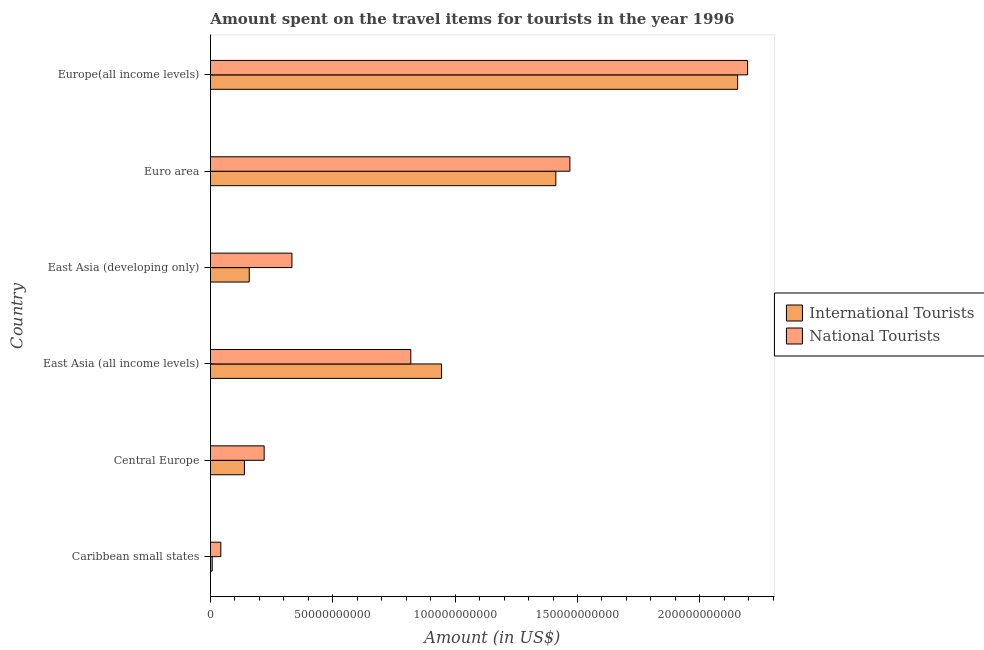Are the number of bars per tick equal to the number of legend labels?
Ensure brevity in your answer.  Yes. Are the number of bars on each tick of the Y-axis equal?
Keep it short and to the point. Yes. How many bars are there on the 2nd tick from the top?
Ensure brevity in your answer.  2. What is the label of the 2nd group of bars from the top?
Your answer should be very brief. Euro area. What is the amount spent on travel items of national tourists in East Asia (all income levels)?
Make the answer very short. 8.19e+1. Across all countries, what is the maximum amount spent on travel items of national tourists?
Provide a succinct answer. 2.20e+11. Across all countries, what is the minimum amount spent on travel items of international tourists?
Make the answer very short. 7.15e+08. In which country was the amount spent on travel items of national tourists maximum?
Your answer should be compact. Europe(all income levels). In which country was the amount spent on travel items of international tourists minimum?
Offer a terse response. Caribbean small states. What is the total amount spent on travel items of national tourists in the graph?
Your answer should be very brief. 5.08e+11. What is the difference between the amount spent on travel items of national tourists in Central Europe and that in Euro area?
Provide a short and direct response. -1.25e+11. What is the difference between the amount spent on travel items of international tourists in Europe(all income levels) and the amount spent on travel items of national tourists in East Asia (all income levels)?
Offer a terse response. 1.34e+11. What is the average amount spent on travel items of national tourists per country?
Your response must be concise. 8.46e+1. What is the difference between the amount spent on travel items of national tourists and amount spent on travel items of international tourists in Caribbean small states?
Your response must be concise. 3.51e+09. In how many countries, is the amount spent on travel items of national tourists greater than 90000000000 US$?
Give a very brief answer. 2. What is the ratio of the amount spent on travel items of international tourists in Central Europe to that in Euro area?
Your answer should be very brief. 0.1. What is the difference between the highest and the second highest amount spent on travel items of national tourists?
Offer a very short reply. 7.26e+1. What is the difference between the highest and the lowest amount spent on travel items of international tourists?
Your answer should be very brief. 2.15e+11. In how many countries, is the amount spent on travel items of national tourists greater than the average amount spent on travel items of national tourists taken over all countries?
Offer a very short reply. 2. What does the 2nd bar from the top in East Asia (all income levels) represents?
Your answer should be compact. International Tourists. What does the 1st bar from the bottom in Central Europe represents?
Offer a terse response. International Tourists. Are all the bars in the graph horizontal?
Ensure brevity in your answer.  Yes. What is the difference between two consecutive major ticks on the X-axis?
Your answer should be compact. 5.00e+1. Does the graph contain grids?
Ensure brevity in your answer.  No. Where does the legend appear in the graph?
Offer a very short reply. Center right. What is the title of the graph?
Provide a succinct answer. Amount spent on the travel items for tourists in the year 1996. What is the label or title of the Y-axis?
Offer a terse response. Country. What is the Amount (in US$) of International Tourists in Caribbean small states?
Provide a succinct answer. 7.15e+08. What is the Amount (in US$) in National Tourists in Caribbean small states?
Offer a very short reply. 4.22e+09. What is the Amount (in US$) of International Tourists in Central Europe?
Provide a short and direct response. 1.39e+1. What is the Amount (in US$) of National Tourists in Central Europe?
Your answer should be compact. 2.19e+1. What is the Amount (in US$) in International Tourists in East Asia (all income levels)?
Give a very brief answer. 9.44e+1. What is the Amount (in US$) in National Tourists in East Asia (all income levels)?
Provide a short and direct response. 8.19e+1. What is the Amount (in US$) in International Tourists in East Asia (developing only)?
Your answer should be very brief. 1.59e+1. What is the Amount (in US$) of National Tourists in East Asia (developing only)?
Your response must be concise. 3.33e+1. What is the Amount (in US$) of International Tourists in Euro area?
Keep it short and to the point. 1.41e+11. What is the Amount (in US$) of National Tourists in Euro area?
Keep it short and to the point. 1.47e+11. What is the Amount (in US$) in International Tourists in Europe(all income levels)?
Your response must be concise. 2.15e+11. What is the Amount (in US$) in National Tourists in Europe(all income levels)?
Offer a very short reply. 2.20e+11. Across all countries, what is the maximum Amount (in US$) in International Tourists?
Offer a terse response. 2.15e+11. Across all countries, what is the maximum Amount (in US$) of National Tourists?
Keep it short and to the point. 2.20e+11. Across all countries, what is the minimum Amount (in US$) in International Tourists?
Provide a succinct answer. 7.15e+08. Across all countries, what is the minimum Amount (in US$) of National Tourists?
Provide a short and direct response. 4.22e+09. What is the total Amount (in US$) of International Tourists in the graph?
Offer a terse response. 4.81e+11. What is the total Amount (in US$) of National Tourists in the graph?
Ensure brevity in your answer.  5.08e+11. What is the difference between the Amount (in US$) of International Tourists in Caribbean small states and that in Central Europe?
Keep it short and to the point. -1.32e+1. What is the difference between the Amount (in US$) of National Tourists in Caribbean small states and that in Central Europe?
Ensure brevity in your answer.  -1.77e+1. What is the difference between the Amount (in US$) of International Tourists in Caribbean small states and that in East Asia (all income levels)?
Give a very brief answer. -9.37e+1. What is the difference between the Amount (in US$) in National Tourists in Caribbean small states and that in East Asia (all income levels)?
Make the answer very short. -7.77e+1. What is the difference between the Amount (in US$) in International Tourists in Caribbean small states and that in East Asia (developing only)?
Your response must be concise. -1.51e+1. What is the difference between the Amount (in US$) of National Tourists in Caribbean small states and that in East Asia (developing only)?
Give a very brief answer. -2.91e+1. What is the difference between the Amount (in US$) of International Tourists in Caribbean small states and that in Euro area?
Offer a very short reply. -1.40e+11. What is the difference between the Amount (in US$) in National Tourists in Caribbean small states and that in Euro area?
Offer a terse response. -1.43e+11. What is the difference between the Amount (in US$) of International Tourists in Caribbean small states and that in Europe(all income levels)?
Provide a short and direct response. -2.15e+11. What is the difference between the Amount (in US$) of National Tourists in Caribbean small states and that in Europe(all income levels)?
Ensure brevity in your answer.  -2.15e+11. What is the difference between the Amount (in US$) in International Tourists in Central Europe and that in East Asia (all income levels)?
Provide a short and direct response. -8.06e+1. What is the difference between the Amount (in US$) in National Tourists in Central Europe and that in East Asia (all income levels)?
Provide a succinct answer. -5.99e+1. What is the difference between the Amount (in US$) in International Tourists in Central Europe and that in East Asia (developing only)?
Offer a very short reply. -1.97e+09. What is the difference between the Amount (in US$) in National Tourists in Central Europe and that in East Asia (developing only)?
Give a very brief answer. -1.13e+1. What is the difference between the Amount (in US$) in International Tourists in Central Europe and that in Euro area?
Give a very brief answer. -1.27e+11. What is the difference between the Amount (in US$) of National Tourists in Central Europe and that in Euro area?
Give a very brief answer. -1.25e+11. What is the difference between the Amount (in US$) of International Tourists in Central Europe and that in Europe(all income levels)?
Your response must be concise. -2.02e+11. What is the difference between the Amount (in US$) of National Tourists in Central Europe and that in Europe(all income levels)?
Keep it short and to the point. -1.98e+11. What is the difference between the Amount (in US$) in International Tourists in East Asia (all income levels) and that in East Asia (developing only)?
Provide a succinct answer. 7.86e+1. What is the difference between the Amount (in US$) of National Tourists in East Asia (all income levels) and that in East Asia (developing only)?
Your answer should be compact. 4.86e+1. What is the difference between the Amount (in US$) in International Tourists in East Asia (all income levels) and that in Euro area?
Ensure brevity in your answer.  -4.67e+1. What is the difference between the Amount (in US$) of National Tourists in East Asia (all income levels) and that in Euro area?
Offer a terse response. -6.50e+1. What is the difference between the Amount (in US$) in International Tourists in East Asia (all income levels) and that in Europe(all income levels)?
Your answer should be compact. -1.21e+11. What is the difference between the Amount (in US$) of National Tourists in East Asia (all income levels) and that in Europe(all income levels)?
Your answer should be compact. -1.38e+11. What is the difference between the Amount (in US$) of International Tourists in East Asia (developing only) and that in Euro area?
Give a very brief answer. -1.25e+11. What is the difference between the Amount (in US$) in National Tourists in East Asia (developing only) and that in Euro area?
Provide a short and direct response. -1.14e+11. What is the difference between the Amount (in US$) of International Tourists in East Asia (developing only) and that in Europe(all income levels)?
Your response must be concise. -2.00e+11. What is the difference between the Amount (in US$) in National Tourists in East Asia (developing only) and that in Europe(all income levels)?
Your answer should be very brief. -1.86e+11. What is the difference between the Amount (in US$) of International Tourists in Euro area and that in Europe(all income levels)?
Your answer should be compact. -7.43e+1. What is the difference between the Amount (in US$) of National Tourists in Euro area and that in Europe(all income levels)?
Ensure brevity in your answer.  -7.26e+1. What is the difference between the Amount (in US$) of International Tourists in Caribbean small states and the Amount (in US$) of National Tourists in Central Europe?
Keep it short and to the point. -2.12e+1. What is the difference between the Amount (in US$) in International Tourists in Caribbean small states and the Amount (in US$) in National Tourists in East Asia (all income levels)?
Keep it short and to the point. -8.12e+1. What is the difference between the Amount (in US$) of International Tourists in Caribbean small states and the Amount (in US$) of National Tourists in East Asia (developing only)?
Make the answer very short. -3.26e+1. What is the difference between the Amount (in US$) of International Tourists in Caribbean small states and the Amount (in US$) of National Tourists in Euro area?
Offer a very short reply. -1.46e+11. What is the difference between the Amount (in US$) in International Tourists in Caribbean small states and the Amount (in US$) in National Tourists in Europe(all income levels)?
Provide a short and direct response. -2.19e+11. What is the difference between the Amount (in US$) in International Tourists in Central Europe and the Amount (in US$) in National Tourists in East Asia (all income levels)?
Make the answer very short. -6.80e+1. What is the difference between the Amount (in US$) in International Tourists in Central Europe and the Amount (in US$) in National Tourists in East Asia (developing only)?
Make the answer very short. -1.94e+1. What is the difference between the Amount (in US$) of International Tourists in Central Europe and the Amount (in US$) of National Tourists in Euro area?
Provide a succinct answer. -1.33e+11. What is the difference between the Amount (in US$) of International Tourists in Central Europe and the Amount (in US$) of National Tourists in Europe(all income levels)?
Give a very brief answer. -2.06e+11. What is the difference between the Amount (in US$) of International Tourists in East Asia (all income levels) and the Amount (in US$) of National Tourists in East Asia (developing only)?
Give a very brief answer. 6.11e+1. What is the difference between the Amount (in US$) in International Tourists in East Asia (all income levels) and the Amount (in US$) in National Tourists in Euro area?
Provide a short and direct response. -5.25e+1. What is the difference between the Amount (in US$) in International Tourists in East Asia (all income levels) and the Amount (in US$) in National Tourists in Europe(all income levels)?
Ensure brevity in your answer.  -1.25e+11. What is the difference between the Amount (in US$) in International Tourists in East Asia (developing only) and the Amount (in US$) in National Tourists in Euro area?
Offer a very short reply. -1.31e+11. What is the difference between the Amount (in US$) of International Tourists in East Asia (developing only) and the Amount (in US$) of National Tourists in Europe(all income levels)?
Your answer should be compact. -2.04e+11. What is the difference between the Amount (in US$) of International Tourists in Euro area and the Amount (in US$) of National Tourists in Europe(all income levels)?
Provide a short and direct response. -7.84e+1. What is the average Amount (in US$) of International Tourists per country?
Your answer should be compact. 8.02e+1. What is the average Amount (in US$) in National Tourists per country?
Offer a terse response. 8.46e+1. What is the difference between the Amount (in US$) of International Tourists and Amount (in US$) of National Tourists in Caribbean small states?
Give a very brief answer. -3.51e+09. What is the difference between the Amount (in US$) of International Tourists and Amount (in US$) of National Tourists in Central Europe?
Keep it short and to the point. -8.06e+09. What is the difference between the Amount (in US$) in International Tourists and Amount (in US$) in National Tourists in East Asia (all income levels)?
Offer a very short reply. 1.26e+1. What is the difference between the Amount (in US$) of International Tourists and Amount (in US$) of National Tourists in East Asia (developing only)?
Give a very brief answer. -1.74e+1. What is the difference between the Amount (in US$) of International Tourists and Amount (in US$) of National Tourists in Euro area?
Offer a terse response. -5.74e+09. What is the difference between the Amount (in US$) of International Tourists and Amount (in US$) of National Tourists in Europe(all income levels)?
Your response must be concise. -4.06e+09. What is the ratio of the Amount (in US$) in International Tourists in Caribbean small states to that in Central Europe?
Keep it short and to the point. 0.05. What is the ratio of the Amount (in US$) in National Tourists in Caribbean small states to that in Central Europe?
Your answer should be compact. 0.19. What is the ratio of the Amount (in US$) of International Tourists in Caribbean small states to that in East Asia (all income levels)?
Keep it short and to the point. 0.01. What is the ratio of the Amount (in US$) of National Tourists in Caribbean small states to that in East Asia (all income levels)?
Your answer should be compact. 0.05. What is the ratio of the Amount (in US$) of International Tourists in Caribbean small states to that in East Asia (developing only)?
Your response must be concise. 0.05. What is the ratio of the Amount (in US$) in National Tourists in Caribbean small states to that in East Asia (developing only)?
Provide a short and direct response. 0.13. What is the ratio of the Amount (in US$) in International Tourists in Caribbean small states to that in Euro area?
Make the answer very short. 0.01. What is the ratio of the Amount (in US$) of National Tourists in Caribbean small states to that in Euro area?
Make the answer very short. 0.03. What is the ratio of the Amount (in US$) of International Tourists in Caribbean small states to that in Europe(all income levels)?
Ensure brevity in your answer.  0. What is the ratio of the Amount (in US$) in National Tourists in Caribbean small states to that in Europe(all income levels)?
Keep it short and to the point. 0.02. What is the ratio of the Amount (in US$) of International Tourists in Central Europe to that in East Asia (all income levels)?
Your answer should be compact. 0.15. What is the ratio of the Amount (in US$) of National Tourists in Central Europe to that in East Asia (all income levels)?
Your answer should be compact. 0.27. What is the ratio of the Amount (in US$) in International Tourists in Central Europe to that in East Asia (developing only)?
Your answer should be compact. 0.88. What is the ratio of the Amount (in US$) of National Tourists in Central Europe to that in East Asia (developing only)?
Offer a very short reply. 0.66. What is the ratio of the Amount (in US$) in International Tourists in Central Europe to that in Euro area?
Offer a terse response. 0.1. What is the ratio of the Amount (in US$) in National Tourists in Central Europe to that in Euro area?
Offer a very short reply. 0.15. What is the ratio of the Amount (in US$) of International Tourists in Central Europe to that in Europe(all income levels)?
Provide a succinct answer. 0.06. What is the ratio of the Amount (in US$) in National Tourists in Central Europe to that in Europe(all income levels)?
Offer a terse response. 0.1. What is the ratio of the Amount (in US$) of International Tourists in East Asia (all income levels) to that in East Asia (developing only)?
Your answer should be very brief. 5.96. What is the ratio of the Amount (in US$) of National Tourists in East Asia (all income levels) to that in East Asia (developing only)?
Ensure brevity in your answer.  2.46. What is the ratio of the Amount (in US$) in International Tourists in East Asia (all income levels) to that in Euro area?
Your answer should be very brief. 0.67. What is the ratio of the Amount (in US$) of National Tourists in East Asia (all income levels) to that in Euro area?
Provide a succinct answer. 0.56. What is the ratio of the Amount (in US$) in International Tourists in East Asia (all income levels) to that in Europe(all income levels)?
Provide a succinct answer. 0.44. What is the ratio of the Amount (in US$) of National Tourists in East Asia (all income levels) to that in Europe(all income levels)?
Ensure brevity in your answer.  0.37. What is the ratio of the Amount (in US$) in International Tourists in East Asia (developing only) to that in Euro area?
Your response must be concise. 0.11. What is the ratio of the Amount (in US$) of National Tourists in East Asia (developing only) to that in Euro area?
Ensure brevity in your answer.  0.23. What is the ratio of the Amount (in US$) of International Tourists in East Asia (developing only) to that in Europe(all income levels)?
Your answer should be compact. 0.07. What is the ratio of the Amount (in US$) of National Tourists in East Asia (developing only) to that in Europe(all income levels)?
Keep it short and to the point. 0.15. What is the ratio of the Amount (in US$) in International Tourists in Euro area to that in Europe(all income levels)?
Give a very brief answer. 0.66. What is the ratio of the Amount (in US$) in National Tourists in Euro area to that in Europe(all income levels)?
Keep it short and to the point. 0.67. What is the difference between the highest and the second highest Amount (in US$) in International Tourists?
Give a very brief answer. 7.43e+1. What is the difference between the highest and the second highest Amount (in US$) of National Tourists?
Keep it short and to the point. 7.26e+1. What is the difference between the highest and the lowest Amount (in US$) of International Tourists?
Ensure brevity in your answer.  2.15e+11. What is the difference between the highest and the lowest Amount (in US$) in National Tourists?
Offer a very short reply. 2.15e+11. 